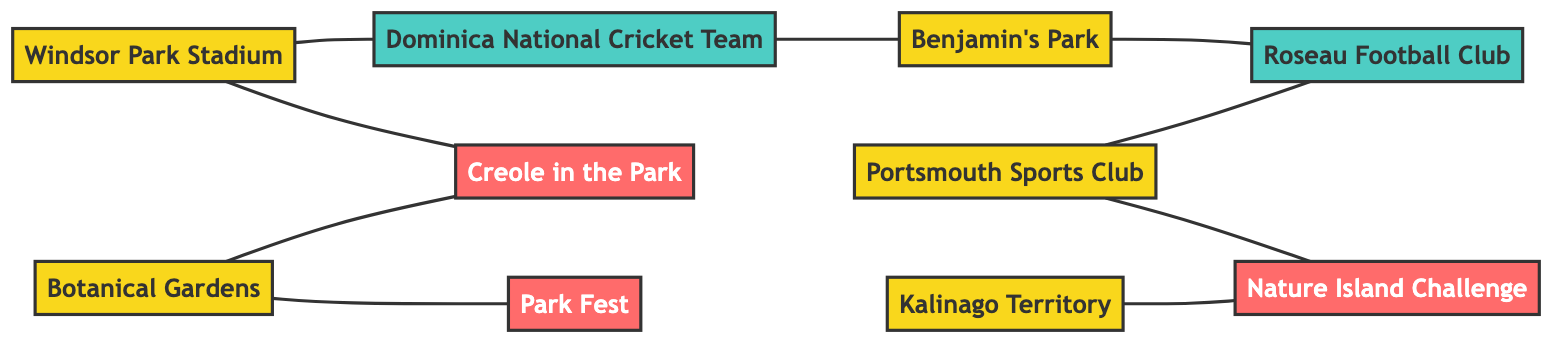What is the total number of venues in the diagram? The diagram lists the following venues: Windsor Park Stadium, Benjamin's Park, Botanical Gardens, Portsmouth Sports Club, and Kalinago Territory. Counting them gives a total of 5 venues.
Answer: 5 Which event is hosted at the Botanical Gardens? The diagram shows that Creole in the Park is connected to the Botanical Gardens with an edge. This indicates that Creole in the Park is hosted at the Botanical Gardens.
Answer: Creole in the Park How many teams are associated with Benjamin's Park? The diagram shows that Benjamin's Park is connected to one team, which is the Roseau Football Club. This indicates that there is one team associated with Benjamin's Park.
Answer: 1 What events are connected to Portsmouth Sports Club? Portsmouth Sports Club is connected to Nature Island Challenge and also to Roseau Football Club. Thus, two events are connected to Portsmouth Sports Club: Nature Island Challenge and Roseau Football Club.
Answer: Nature Island Challenge and Roseau Football Club Is the National Cricket Team associated with Windsor Park Stadium? Yes, the diagram has a direct connection (an edge) from Windsor Park Stadium to the National Cricket Team, indicating they are associated.
Answer: Yes What venue is connected to the event Park Fest? The diagram shows that Park Fest has an edge connecting it to the Botanical Gardens, indicating that Park Fest is associated with the Botanical Gardens.
Answer: Botanical Gardens Which team is connected to the Benjamin's Park? The diagram shows that Benjamin's Park is connected to Roseau Football Club. Thus, Roseau Football Club is the team associated with Benjamin's Park.
Answer: Roseau Football Club How many edges are there in the diagram? By counting the edges shown between the nodes, we find there are a total of 8 edges in the diagram.
Answer: 8 